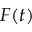Convert formula to latex. <formula><loc_0><loc_0><loc_500><loc_500>F ( t )</formula> 